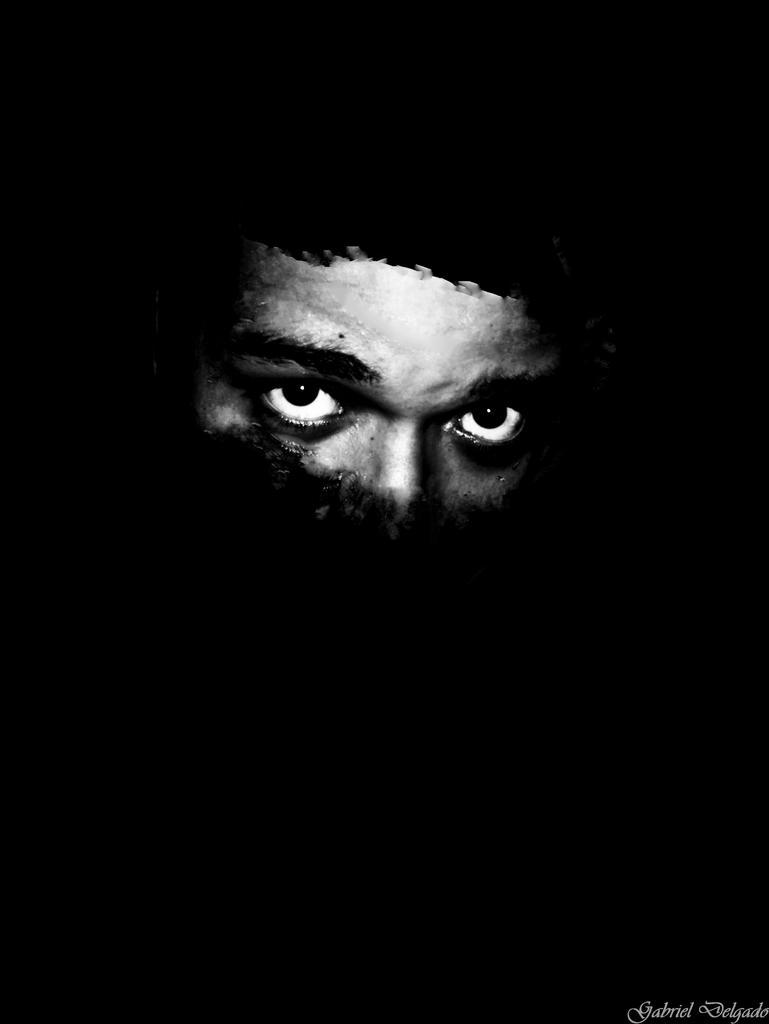Can you describe this image briefly? In the picture we can see face of a person. 